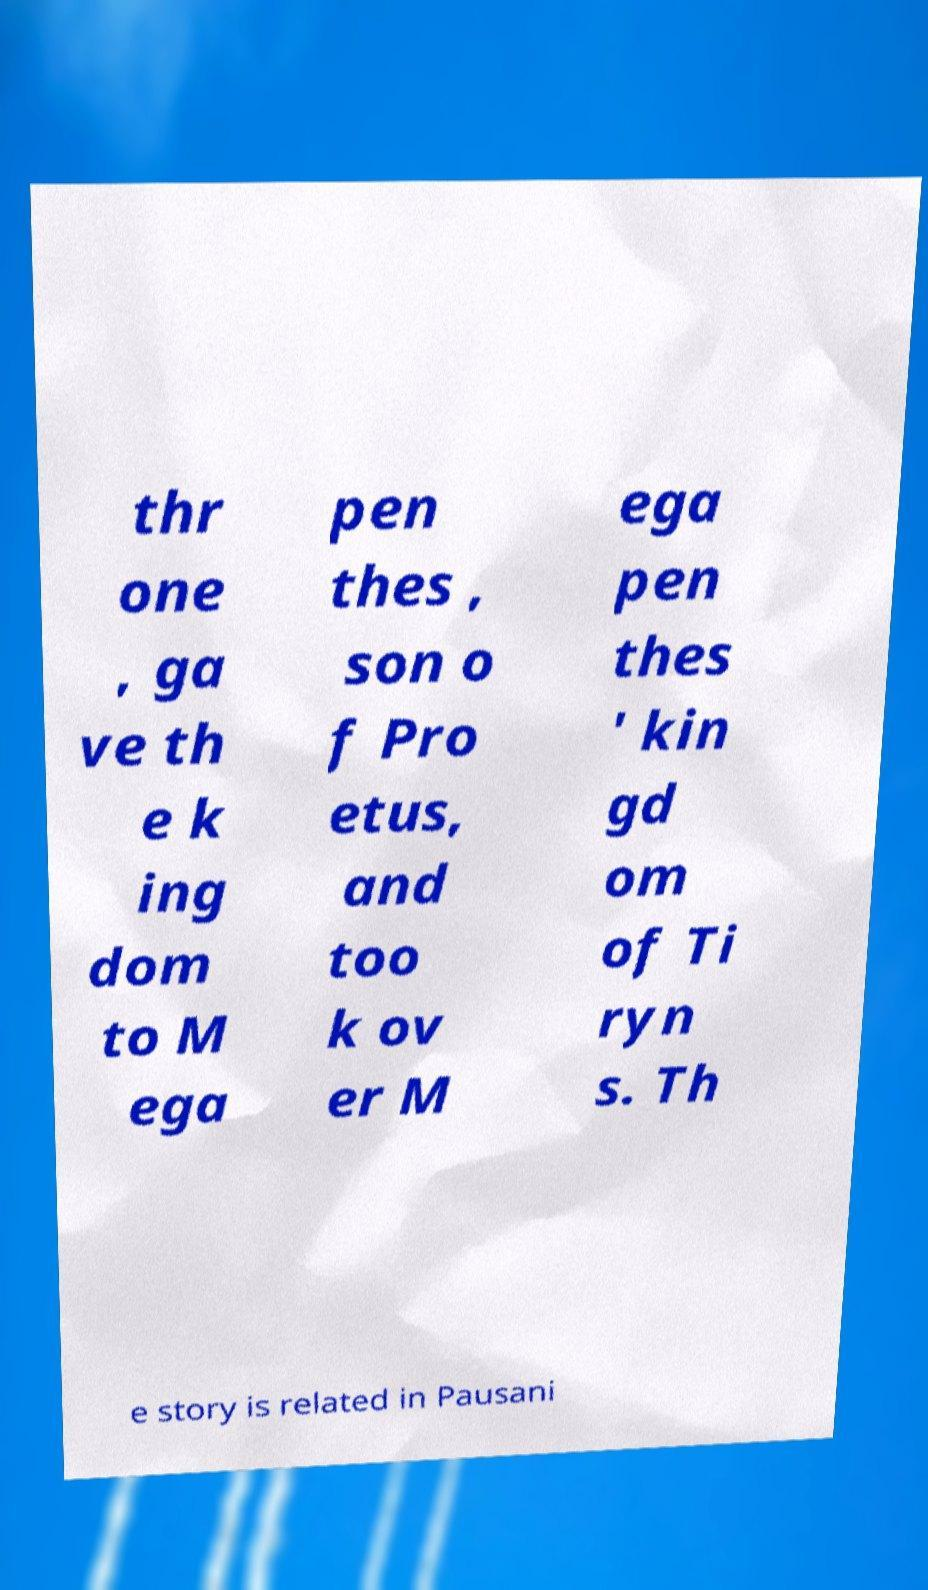For documentation purposes, I need the text within this image transcribed. Could you provide that? thr one , ga ve th e k ing dom to M ega pen thes , son o f Pro etus, and too k ov er M ega pen thes ' kin gd om of Ti ryn s. Th e story is related in Pausani 